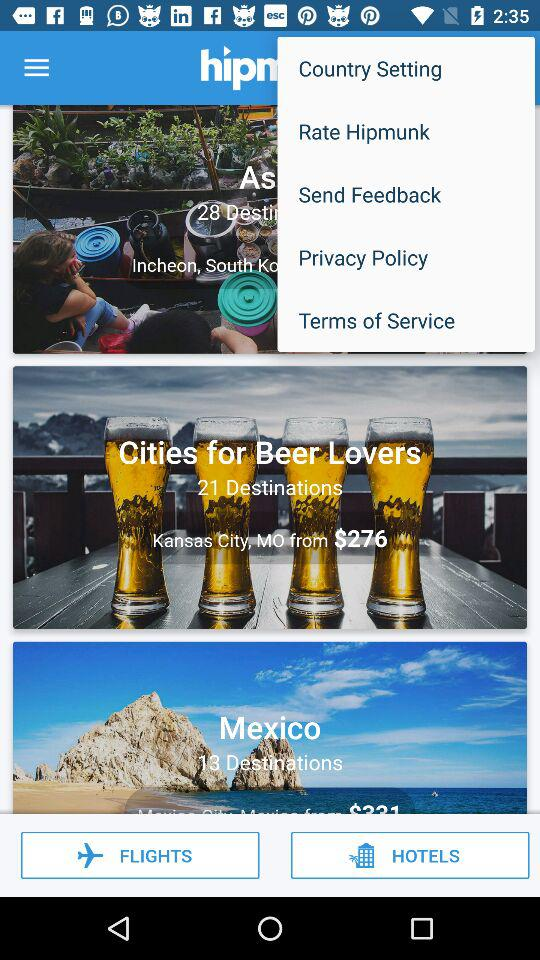What is the name of the city for beer lovers? The name of the city for beer lovers is Kansas City. 